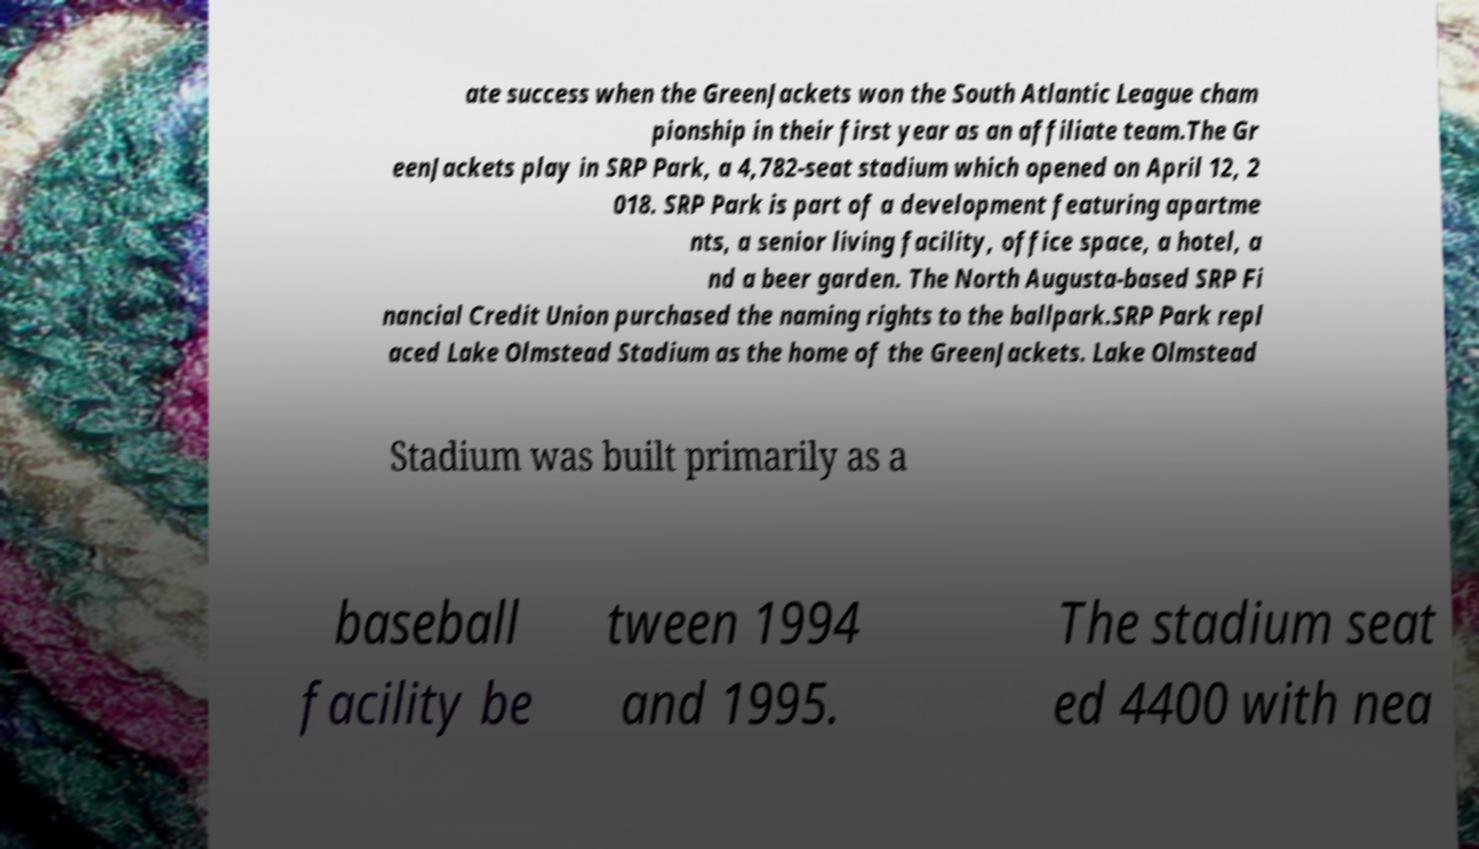Can you accurately transcribe the text from the provided image for me? ate success when the GreenJackets won the South Atlantic League cham pionship in their first year as an affiliate team.The Gr eenJackets play in SRP Park, a 4,782-seat stadium which opened on April 12, 2 018. SRP Park is part of a development featuring apartme nts, a senior living facility, office space, a hotel, a nd a beer garden. The North Augusta-based SRP Fi nancial Credit Union purchased the naming rights to the ballpark.SRP Park repl aced Lake Olmstead Stadium as the home of the GreenJackets. Lake Olmstead Stadium was built primarily as a baseball facility be tween 1994 and 1995. The stadium seat ed 4400 with nea 